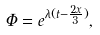Convert formula to latex. <formula><loc_0><loc_0><loc_500><loc_500>\Phi = e ^ { \lambda ( t - \frac { 2 x } { 3 } ) } ,</formula> 